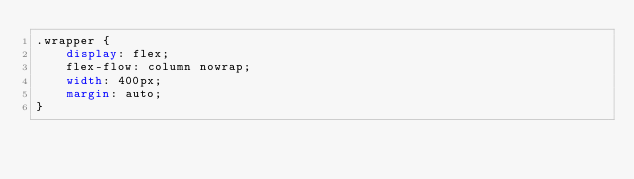<code> <loc_0><loc_0><loc_500><loc_500><_CSS_>.wrapper {
    display: flex;
    flex-flow: column nowrap;
    width: 400px;
    margin: auto;
}</code> 